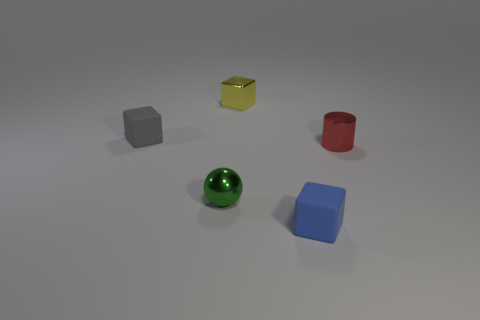Is the number of green metal spheres that are to the right of the shiny cylinder greater than the number of metal things right of the tiny yellow thing?
Your answer should be compact. No. There is a small metallic cylinder; does it have the same color as the tiny cube that is behind the tiny gray block?
Ensure brevity in your answer.  No. What is the material of the gray thing that is the same size as the green ball?
Your answer should be compact. Rubber. How many objects are red cylinders or tiny things behind the gray matte block?
Provide a succinct answer. 2. There is a red thing; is its size the same as the matte cube behind the ball?
Your answer should be compact. Yes. How many blocks are green objects or tiny objects?
Offer a terse response. 3. How many tiny objects are both behind the small red thing and in front of the tiny shiny ball?
Keep it short and to the point. 0. How many other objects are there of the same color as the metal block?
Ensure brevity in your answer.  0. What shape is the shiny thing that is on the right side of the yellow metal cube?
Provide a succinct answer. Cylinder. Does the blue thing have the same material as the tiny gray block?
Your answer should be compact. Yes. 